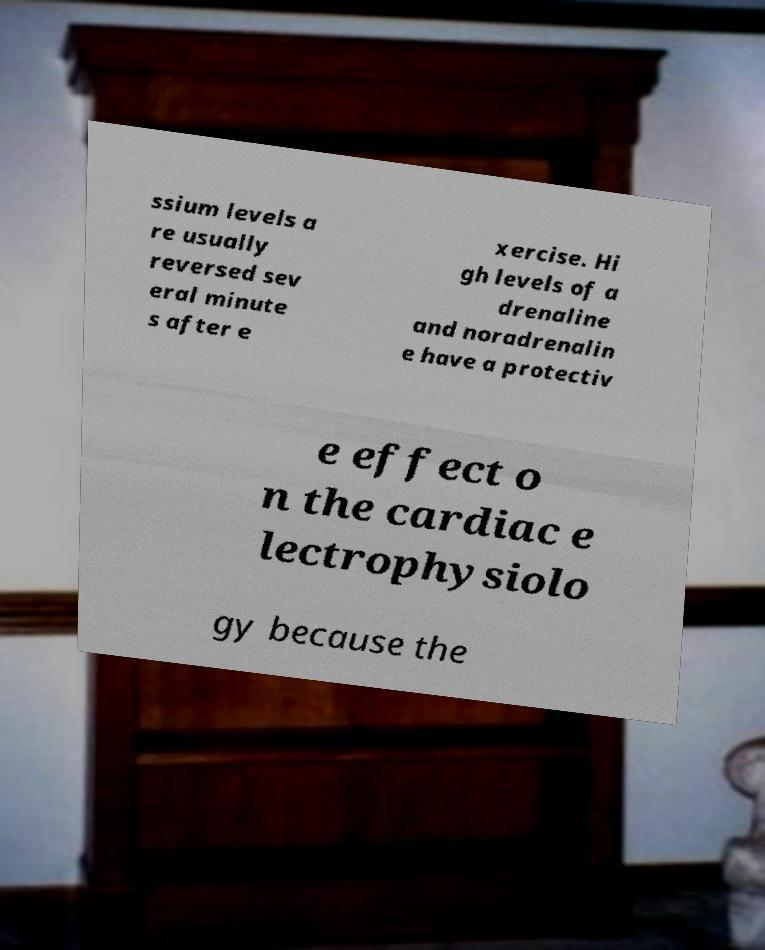Could you extract and type out the text from this image? ssium levels a re usually reversed sev eral minute s after e xercise. Hi gh levels of a drenaline and noradrenalin e have a protectiv e effect o n the cardiac e lectrophysiolo gy because the 